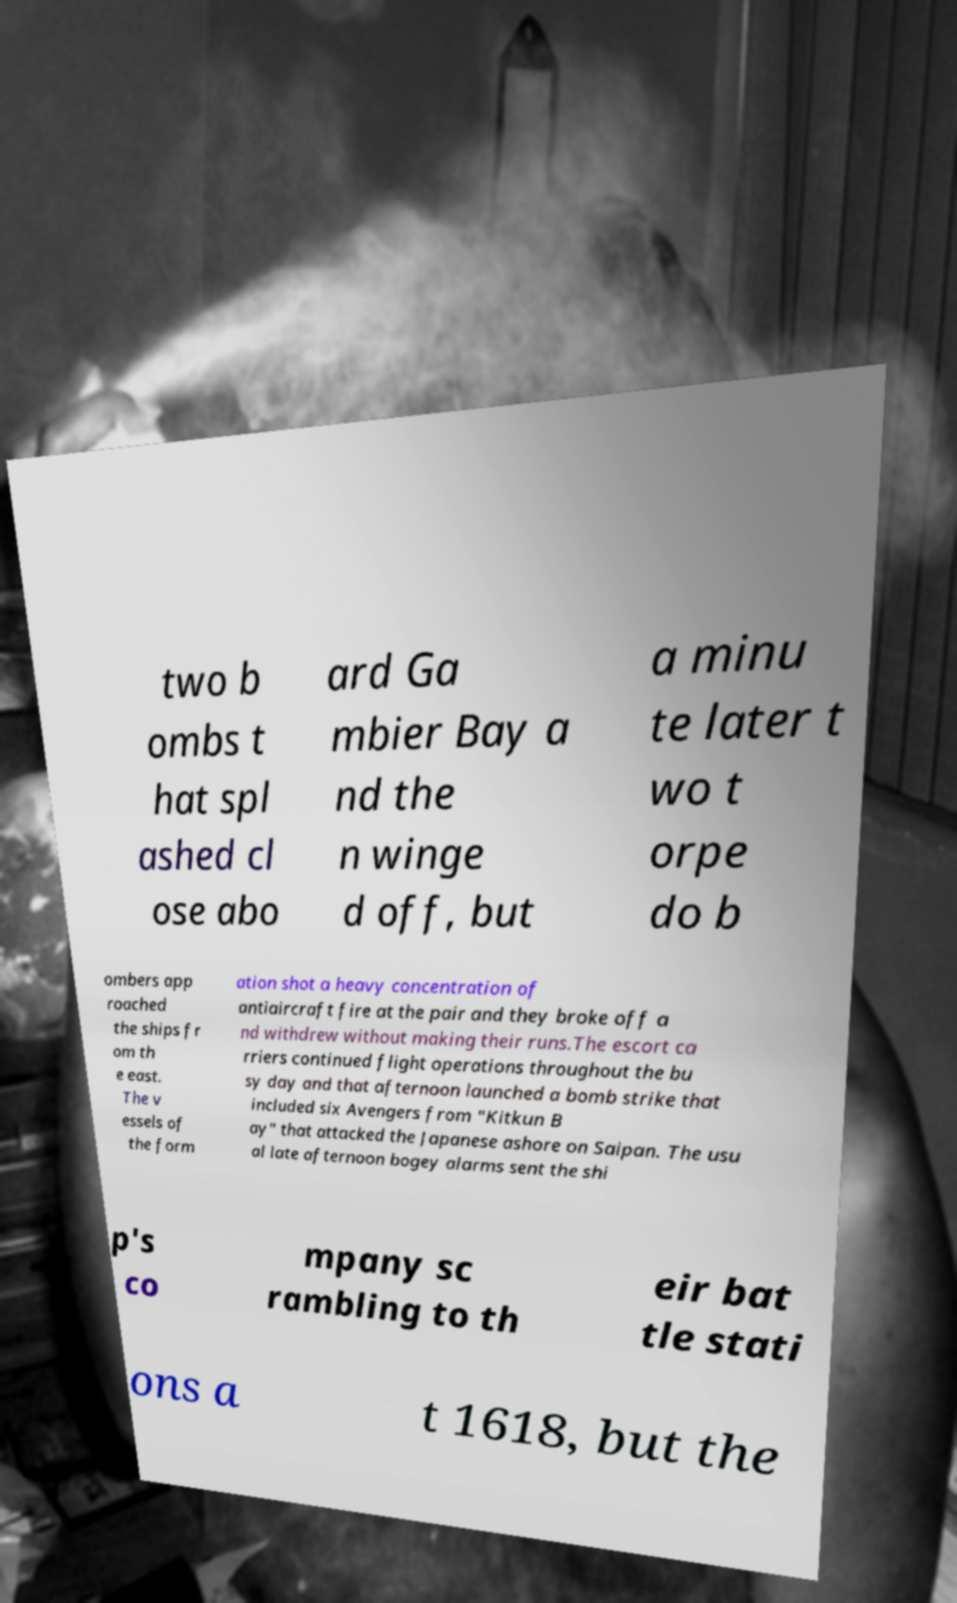Can you read and provide the text displayed in the image?This photo seems to have some interesting text. Can you extract and type it out for me? two b ombs t hat spl ashed cl ose abo ard Ga mbier Bay a nd the n winge d off, but a minu te later t wo t orpe do b ombers app roached the ships fr om th e east. The v essels of the form ation shot a heavy concentration of antiaircraft fire at the pair and they broke off a nd withdrew without making their runs.The escort ca rriers continued flight operations throughout the bu sy day and that afternoon launched a bomb strike that included six Avengers from "Kitkun B ay" that attacked the Japanese ashore on Saipan. The usu al late afternoon bogey alarms sent the shi p's co mpany sc rambling to th eir bat tle stati ons a t 1618, but the 